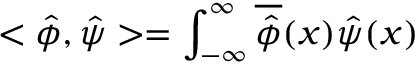Convert formula to latex. <formula><loc_0><loc_0><loc_500><loc_500>< \hat { \phi } , \hat { \psi } > = \int _ { - \infty } ^ { \infty } \overline { { { \hat { \phi } } } } ( x ) \hat { \psi } ( x )</formula> 